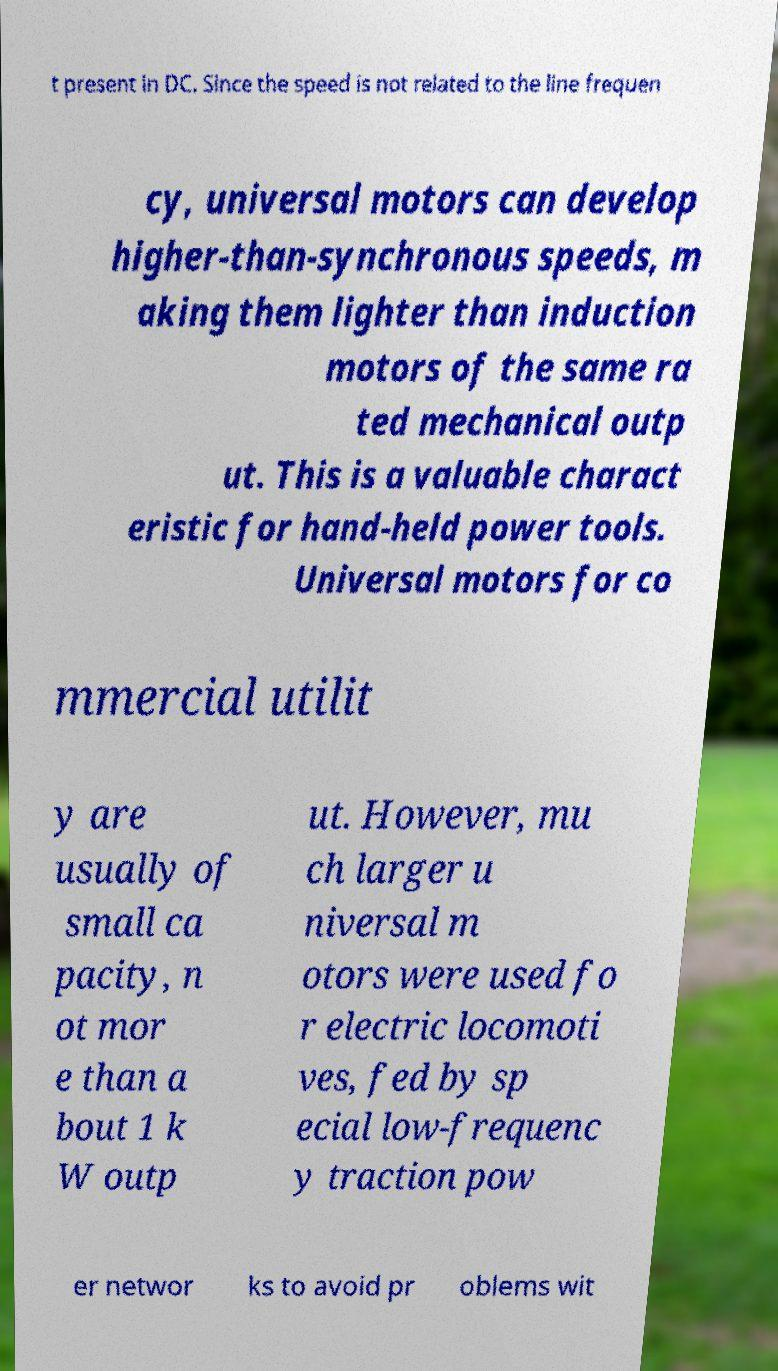There's text embedded in this image that I need extracted. Can you transcribe it verbatim? t present in DC. Since the speed is not related to the line frequen cy, universal motors can develop higher-than-synchronous speeds, m aking them lighter than induction motors of the same ra ted mechanical outp ut. This is a valuable charact eristic for hand-held power tools. Universal motors for co mmercial utilit y are usually of small ca pacity, n ot mor e than a bout 1 k W outp ut. However, mu ch larger u niversal m otors were used fo r electric locomoti ves, fed by sp ecial low-frequenc y traction pow er networ ks to avoid pr oblems wit 